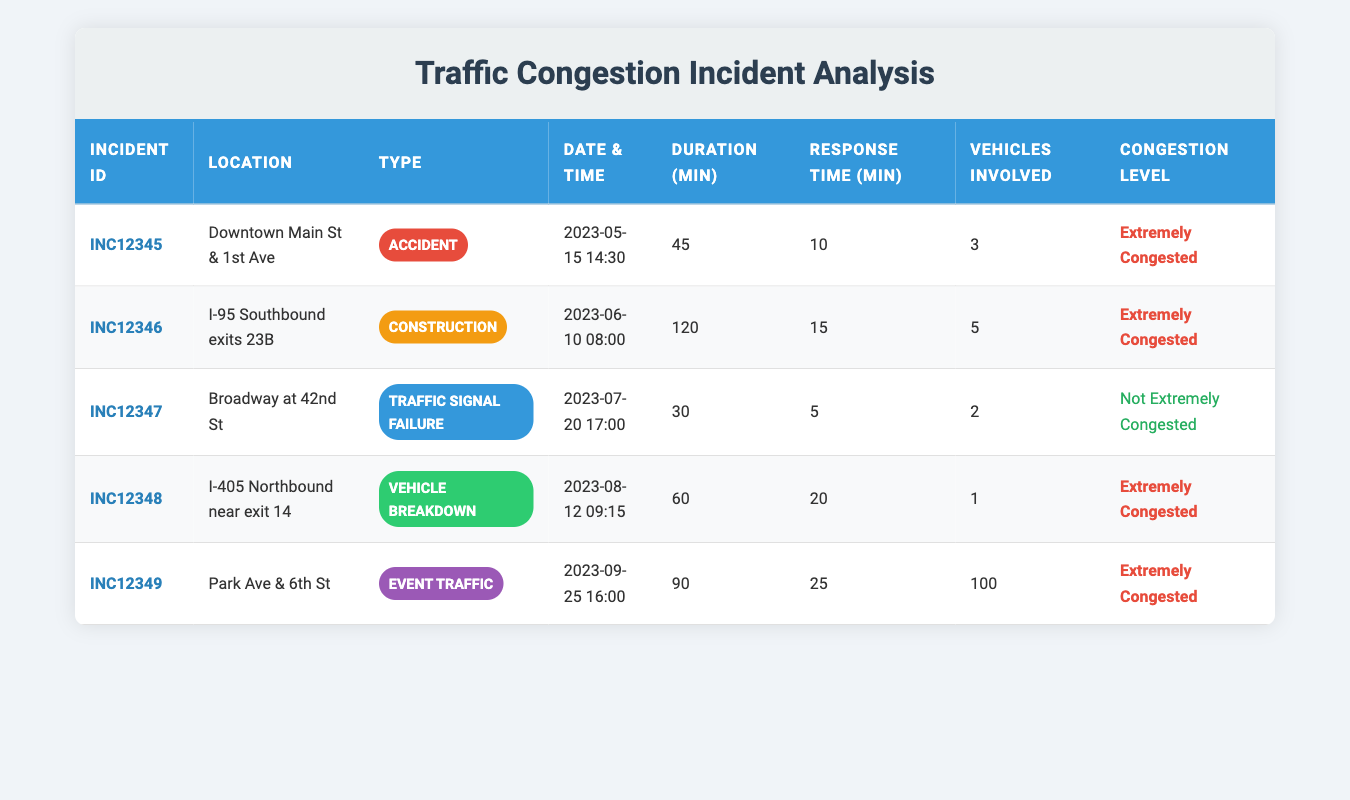What is the total number of vehicles involved in all incidents? To find the total number of vehicles involved, we need to sum the "vehicles_involved" column from each incident: 3 + 5 + 2 + 1 + 100 = 111.
Answer: 111 Which incident had the longest duration? By comparing the "duration_minutes" column, we see that the incident with the longest duration is "INC12346" which lasted for 120 minutes.
Answer: INC12346 Was there any incident that occurred on a weekend? The dates of the incidents are May 15, June 10, July 20, August 12, and September 25. None of these dates fall on a Saturday or Sunday, so there were no weekend incidents.
Answer: No What was the average response time for all incidents? We sum the response times: 10 + 15 + 5 + 20 + 25 = 75 minutes. We have 5 incidents, so the average response time is 75 / 5 = 15 minutes.
Answer: 15 minutes How many incidents were classified as "Extremely Congested"? By checking the "Congestion Level" column, we find 4 incidents marked as "Extremely Congested" out of the 5 incidents listed.
Answer: 4 Is there a correlation between the duration of the incident and the response time? To determine correlation, we can compare values. While the average duration for extremely congested incidents is higher (120, 45, 60, 90 minutes), response times vary, showing no clear correlation without further analysis.
Answer: No clear correlation What type of traffic incident had the least response time? Upon reviewing the response times, "INC12347" (Traffic Signal Failure) had the least response time of 5 minutes.
Answer: INC12347 Identify the month with the most traffic incidents. Checking the incident dates: May, June, July, August, and September. Each month has one incident, so there is no single month with the most incidents; they are all equal.
Answer: No single month has more incidents 